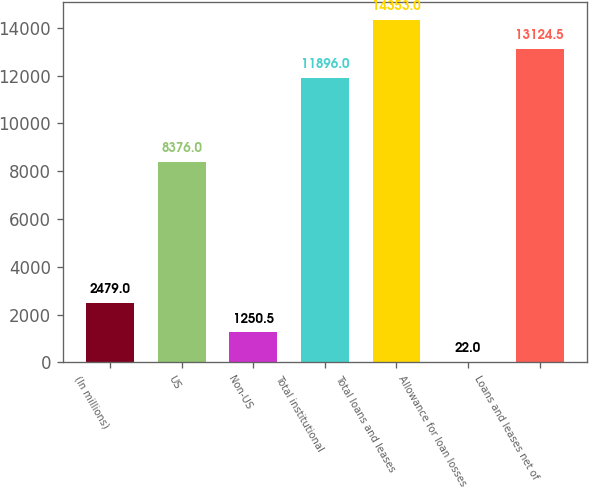<chart> <loc_0><loc_0><loc_500><loc_500><bar_chart><fcel>(In millions)<fcel>US<fcel>Non-US<fcel>Total institutional<fcel>Total loans and leases<fcel>Allowance for loan losses<fcel>Loans and leases net of<nl><fcel>2479<fcel>8376<fcel>1250.5<fcel>11896<fcel>14353<fcel>22<fcel>13124.5<nl></chart> 